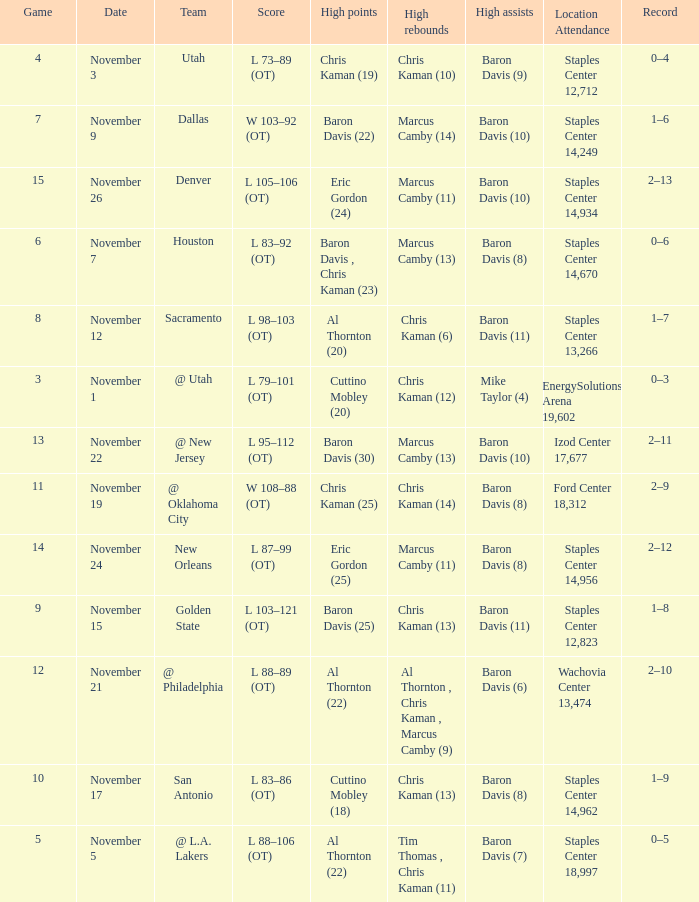Name the total number of score for staples center 13,266 1.0. Could you help me parse every detail presented in this table? {'header': ['Game', 'Date', 'Team', 'Score', 'High points', 'High rebounds', 'High assists', 'Location Attendance', 'Record'], 'rows': [['4', 'November 3', 'Utah', 'L 73–89 (OT)', 'Chris Kaman (19)', 'Chris Kaman (10)', 'Baron Davis (9)', 'Staples Center 12,712', '0–4'], ['7', 'November 9', 'Dallas', 'W 103–92 (OT)', 'Baron Davis (22)', 'Marcus Camby (14)', 'Baron Davis (10)', 'Staples Center 14,249', '1–6'], ['15', 'November 26', 'Denver', 'L 105–106 (OT)', 'Eric Gordon (24)', 'Marcus Camby (11)', 'Baron Davis (10)', 'Staples Center 14,934', '2–13'], ['6', 'November 7', 'Houston', 'L 83–92 (OT)', 'Baron Davis , Chris Kaman (23)', 'Marcus Camby (13)', 'Baron Davis (8)', 'Staples Center 14,670', '0–6'], ['8', 'November 12', 'Sacramento', 'L 98–103 (OT)', 'Al Thornton (20)', 'Chris Kaman (6)', 'Baron Davis (11)', 'Staples Center 13,266', '1–7'], ['3', 'November 1', '@ Utah', 'L 79–101 (OT)', 'Cuttino Mobley (20)', 'Chris Kaman (12)', 'Mike Taylor (4)', 'EnergySolutions Arena 19,602', '0–3'], ['13', 'November 22', '@ New Jersey', 'L 95–112 (OT)', 'Baron Davis (30)', 'Marcus Camby (13)', 'Baron Davis (10)', 'Izod Center 17,677', '2–11'], ['11', 'November 19', '@ Oklahoma City', 'W 108–88 (OT)', 'Chris Kaman (25)', 'Chris Kaman (14)', 'Baron Davis (8)', 'Ford Center 18,312', '2–9'], ['14', 'November 24', 'New Orleans', 'L 87–99 (OT)', 'Eric Gordon (25)', 'Marcus Camby (11)', 'Baron Davis (8)', 'Staples Center 14,956', '2–12'], ['9', 'November 15', 'Golden State', 'L 103–121 (OT)', 'Baron Davis (25)', 'Chris Kaman (13)', 'Baron Davis (11)', 'Staples Center 12,823', '1–8'], ['12', 'November 21', '@ Philadelphia', 'L 88–89 (OT)', 'Al Thornton (22)', 'Al Thornton , Chris Kaman , Marcus Camby (9)', 'Baron Davis (6)', 'Wachovia Center 13,474', '2–10'], ['10', 'November 17', 'San Antonio', 'L 83–86 (OT)', 'Cuttino Mobley (18)', 'Chris Kaman (13)', 'Baron Davis (8)', 'Staples Center 14,962', '1–9'], ['5', 'November 5', '@ L.A. Lakers', 'L 88–106 (OT)', 'Al Thornton (22)', 'Tim Thomas , Chris Kaman (11)', 'Baron Davis (7)', 'Staples Center 18,997', '0–5']]} 